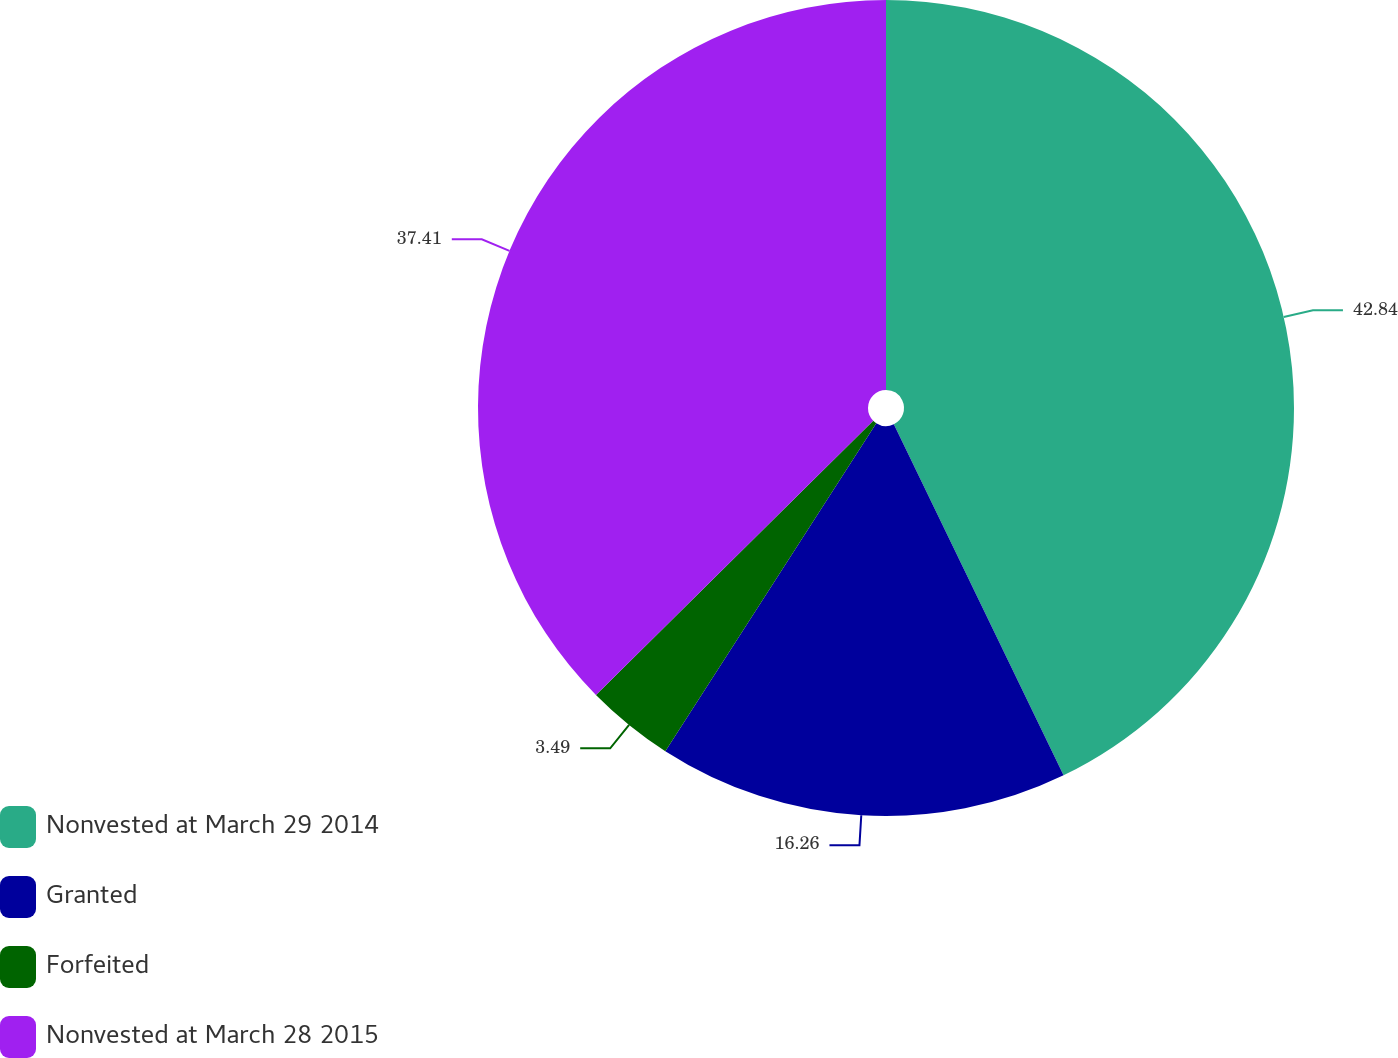<chart> <loc_0><loc_0><loc_500><loc_500><pie_chart><fcel>Nonvested at March 29 2014<fcel>Granted<fcel>Forfeited<fcel>Nonvested at March 28 2015<nl><fcel>42.83%<fcel>16.26%<fcel>3.49%<fcel>37.41%<nl></chart> 